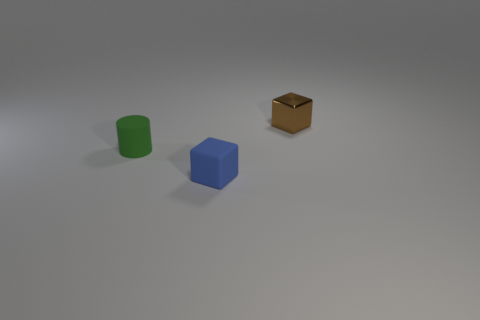Add 3 blue cubes. How many objects exist? 6 Subtract all cylinders. How many objects are left? 2 Subtract all tiny cyan shiny cylinders. Subtract all small cubes. How many objects are left? 1 Add 3 small green objects. How many small green objects are left? 4 Add 1 big green metallic spheres. How many big green metallic spheres exist? 1 Subtract 0 red cylinders. How many objects are left? 3 